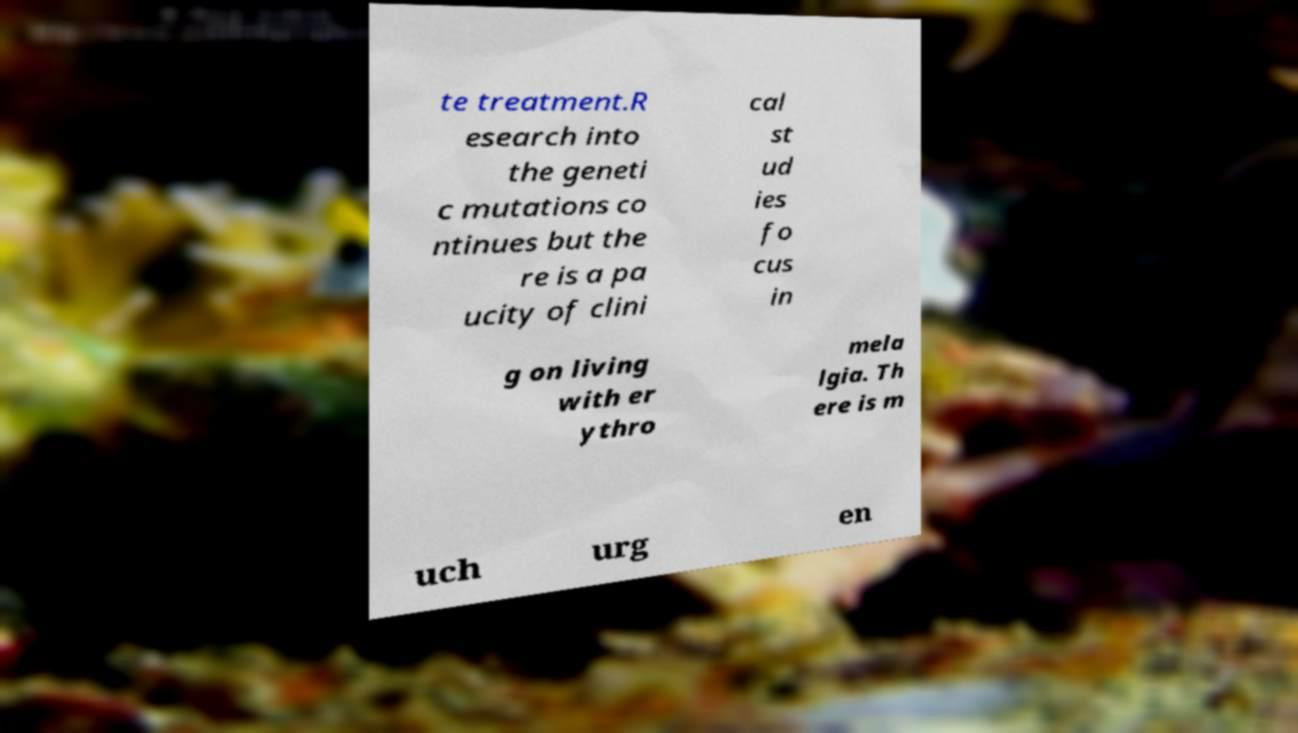There's text embedded in this image that I need extracted. Can you transcribe it verbatim? te treatment.R esearch into the geneti c mutations co ntinues but the re is a pa ucity of clini cal st ud ies fo cus in g on living with er ythro mela lgia. Th ere is m uch urg en 